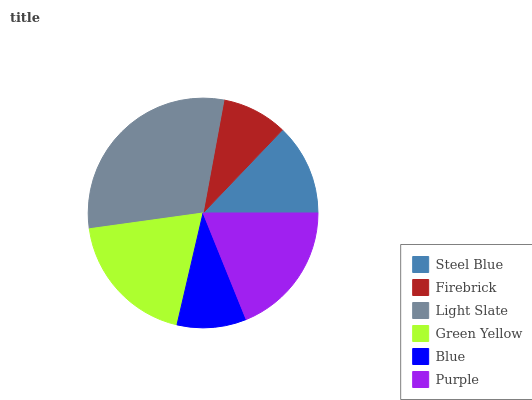Is Firebrick the minimum?
Answer yes or no. Yes. Is Light Slate the maximum?
Answer yes or no. Yes. Is Light Slate the minimum?
Answer yes or no. No. Is Firebrick the maximum?
Answer yes or no. No. Is Light Slate greater than Firebrick?
Answer yes or no. Yes. Is Firebrick less than Light Slate?
Answer yes or no. Yes. Is Firebrick greater than Light Slate?
Answer yes or no. No. Is Light Slate less than Firebrick?
Answer yes or no. No. Is Purple the high median?
Answer yes or no. Yes. Is Steel Blue the low median?
Answer yes or no. Yes. Is Light Slate the high median?
Answer yes or no. No. Is Green Yellow the low median?
Answer yes or no. No. 